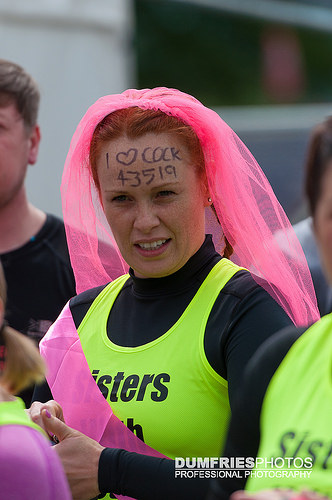<image>
Is the veil behind the head? Yes. From this viewpoint, the veil is positioned behind the head, with the head partially or fully occluding the veil. 